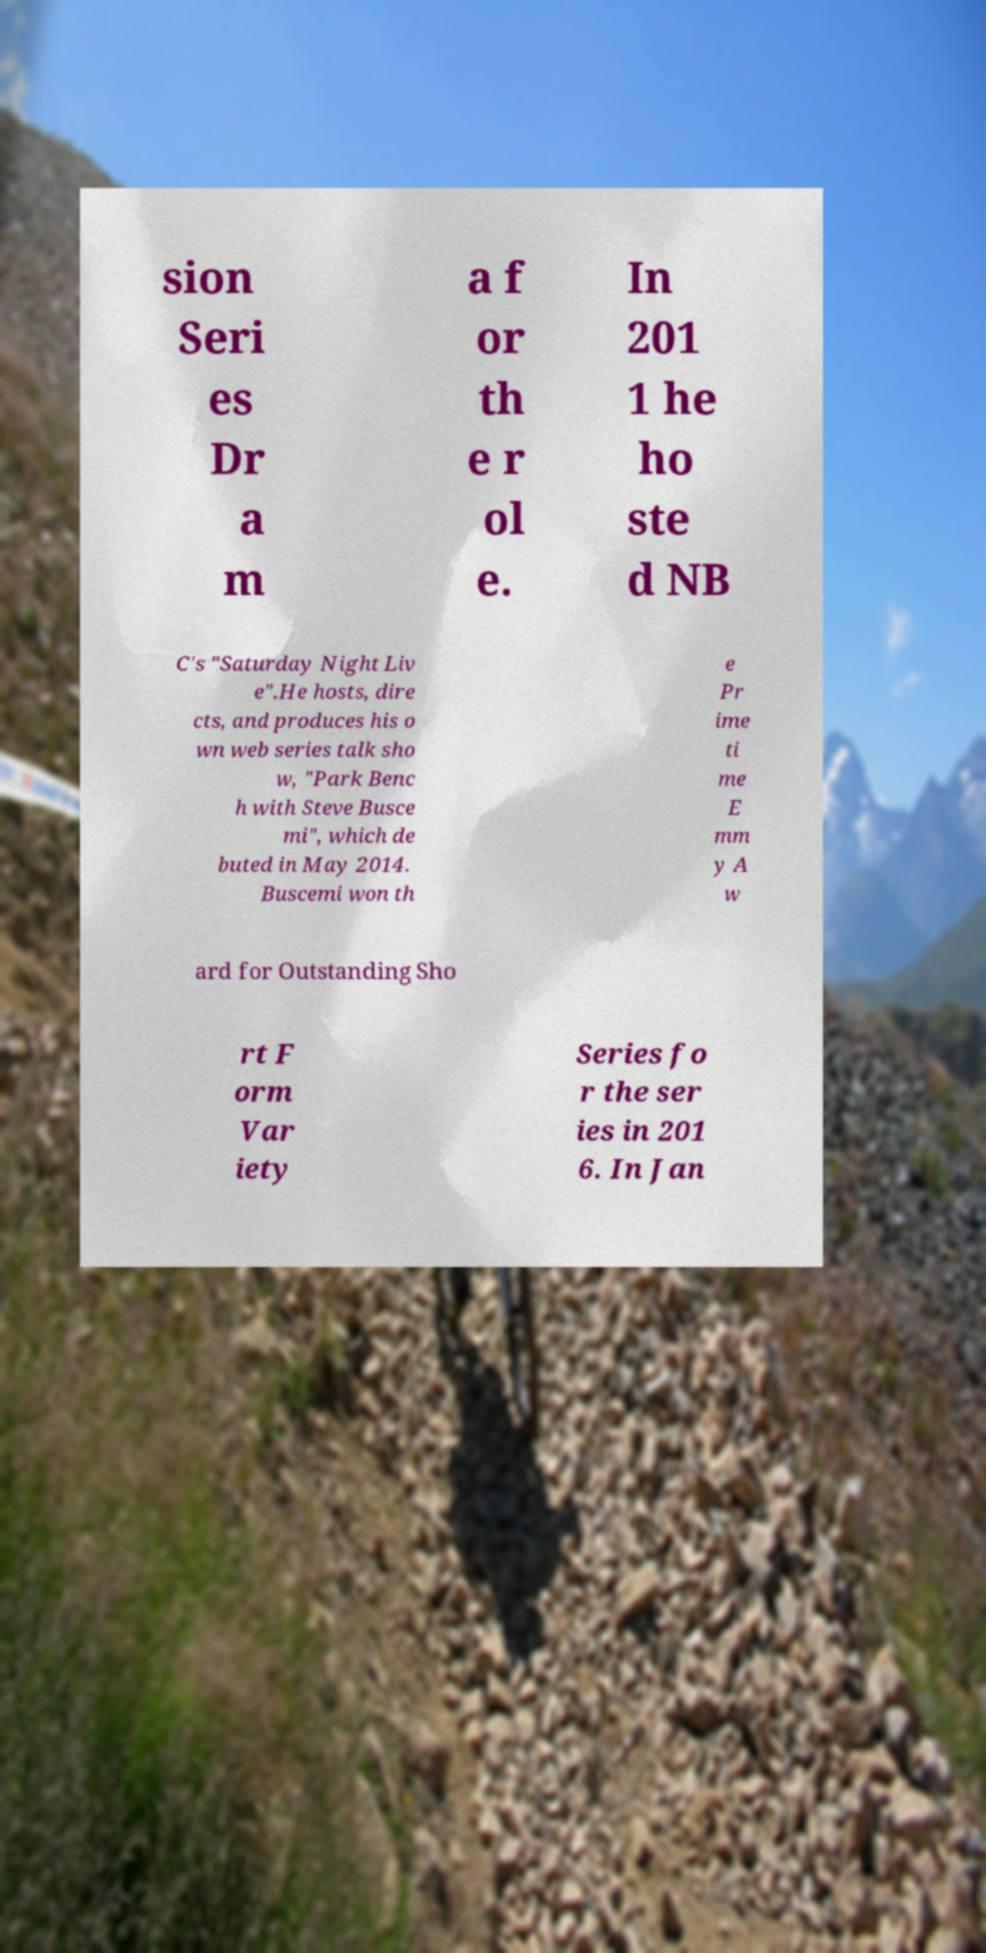Could you extract and type out the text from this image? sion Seri es Dr a m a f or th e r ol e. In 201 1 he ho ste d NB C's "Saturday Night Liv e".He hosts, dire cts, and produces his o wn web series talk sho w, "Park Benc h with Steve Busce mi", which de buted in May 2014. Buscemi won th e Pr ime ti me E mm y A w ard for Outstanding Sho rt F orm Var iety Series fo r the ser ies in 201 6. In Jan 